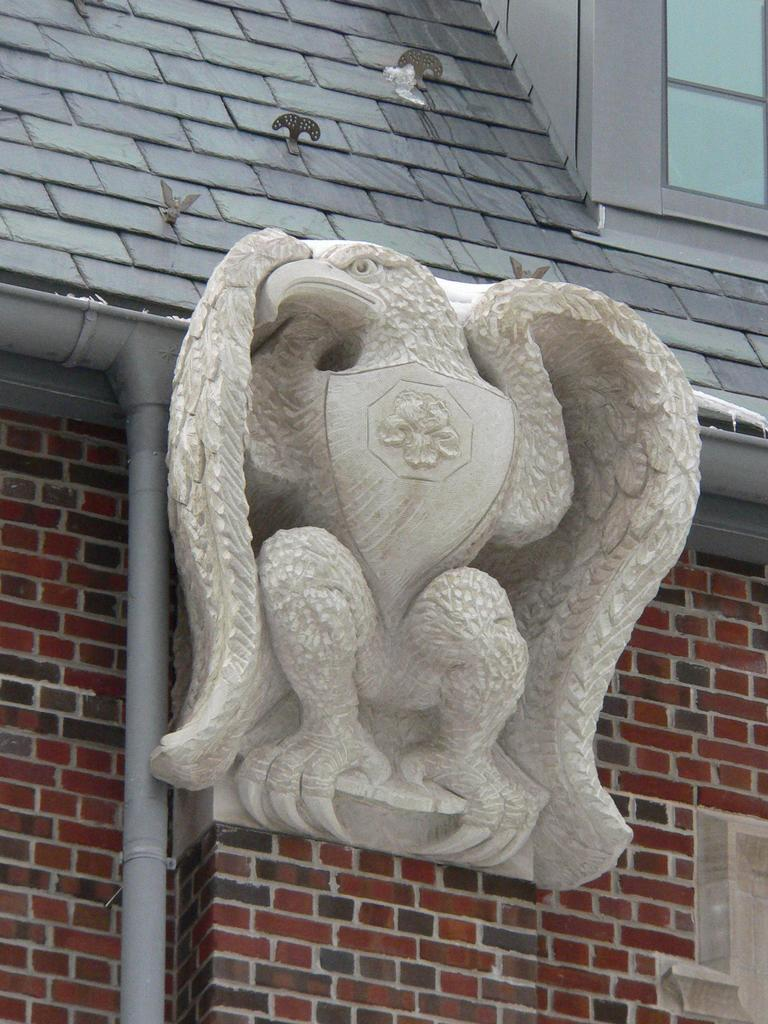What is on the wall in the image? There is a statue on the wall in the image. What can be seen in the image besides the statue? There is a pipe and a window in the image. What is visible on the rooftop in the image? There are objects on the rooftop in the image. Can you see a squirrel holding a pickle on the edge of the window in the image? There is no squirrel holding a pickle on the edge of the window in the image. 